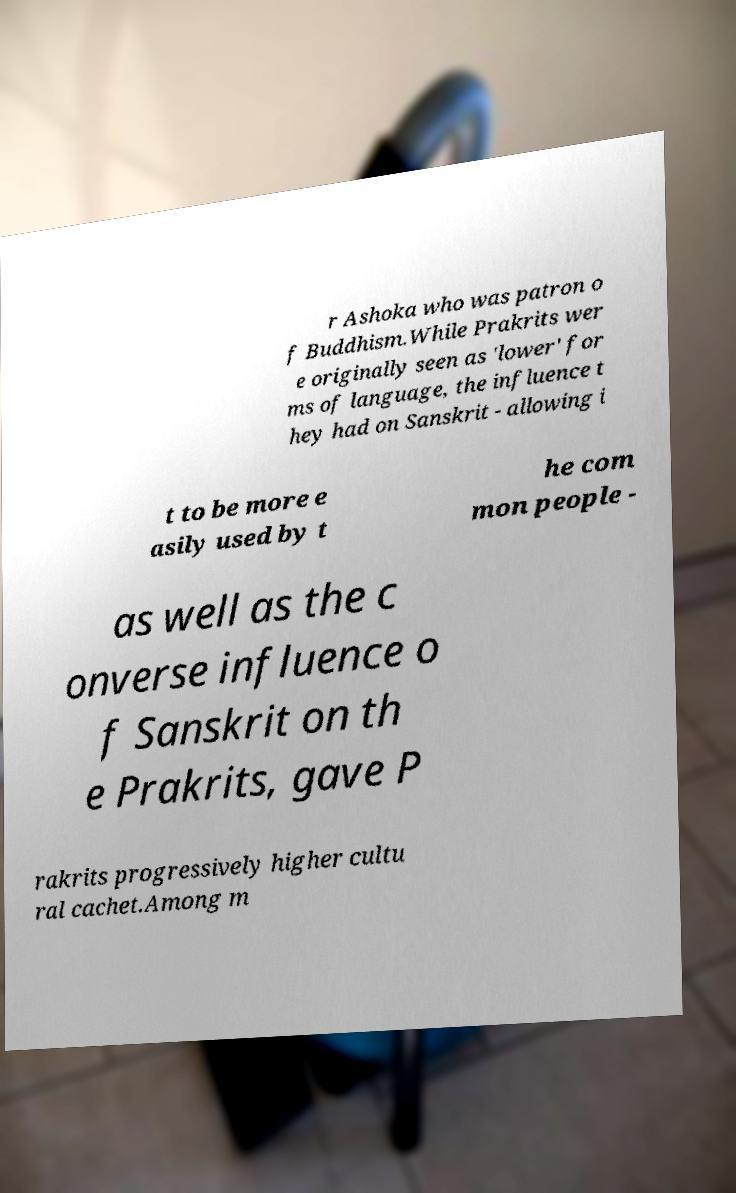I need the written content from this picture converted into text. Can you do that? r Ashoka who was patron o f Buddhism.While Prakrits wer e originally seen as 'lower' for ms of language, the influence t hey had on Sanskrit - allowing i t to be more e asily used by t he com mon people - as well as the c onverse influence o f Sanskrit on th e Prakrits, gave P rakrits progressively higher cultu ral cachet.Among m 